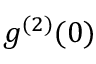Convert formula to latex. <formula><loc_0><loc_0><loc_500><loc_500>g ^ { ( 2 ) } ( 0 )</formula> 